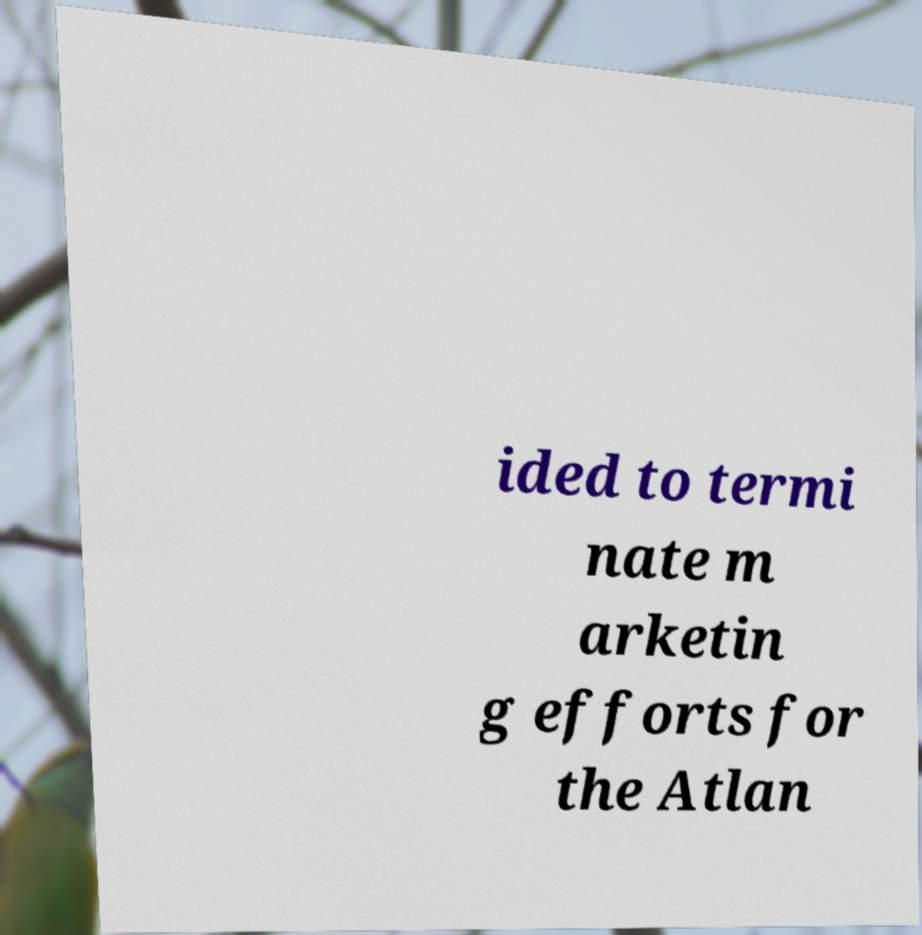Please read and relay the text visible in this image. What does it say? ided to termi nate m arketin g efforts for the Atlan 